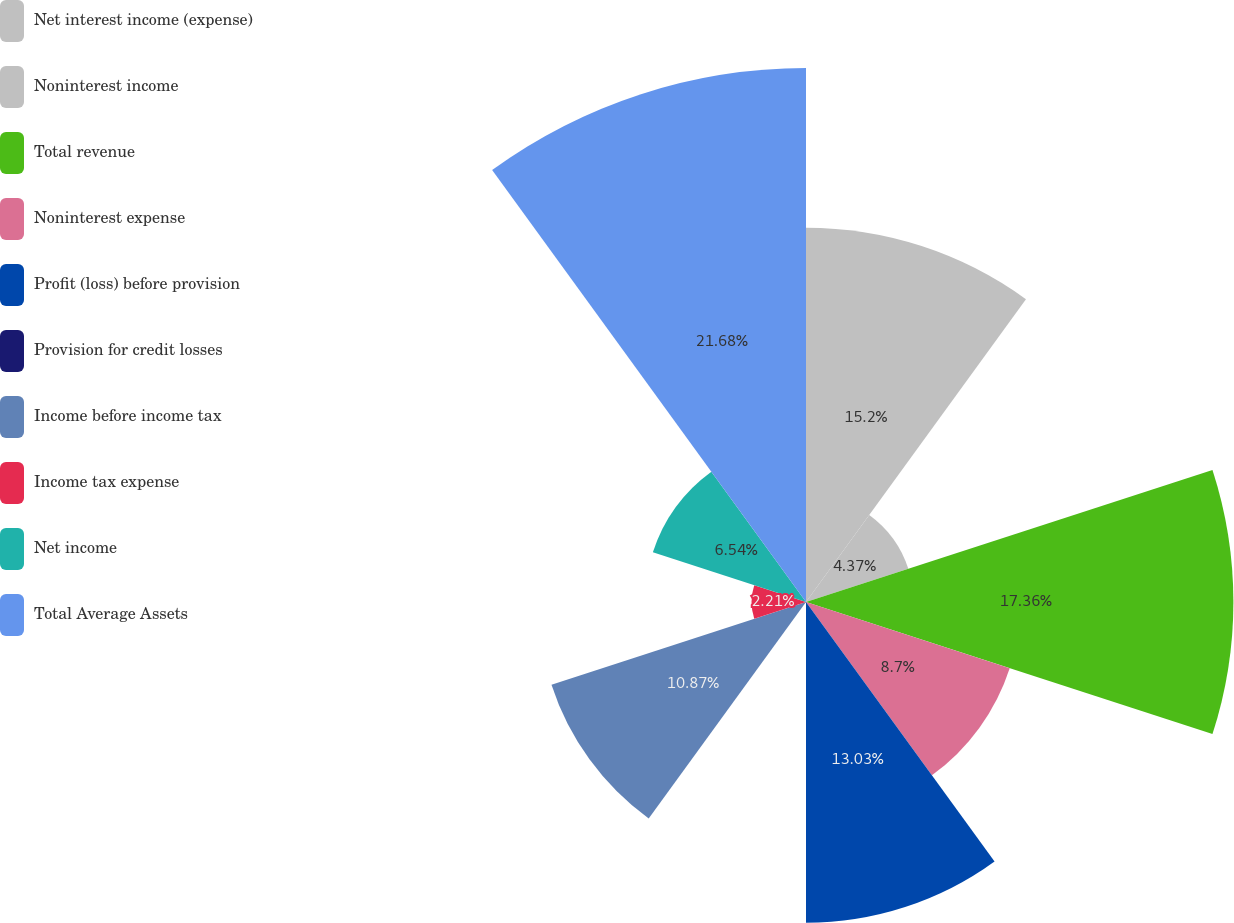Convert chart to OTSL. <chart><loc_0><loc_0><loc_500><loc_500><pie_chart><fcel>Net interest income (expense)<fcel>Noninterest income<fcel>Total revenue<fcel>Noninterest expense<fcel>Profit (loss) before provision<fcel>Provision for credit losses<fcel>Income before income tax<fcel>Income tax expense<fcel>Net income<fcel>Total Average Assets<nl><fcel>15.2%<fcel>4.37%<fcel>17.36%<fcel>8.7%<fcel>13.03%<fcel>0.04%<fcel>10.87%<fcel>2.21%<fcel>6.54%<fcel>21.69%<nl></chart> 